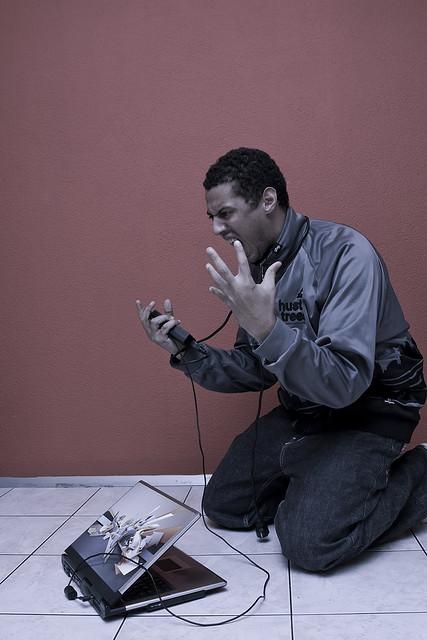Is this man kneeling on linoleum?
Concise answer only. Yes. Is this a cozy room?
Short answer required. No. What emotion is this man feeling?
Write a very short answer. Anger. Is it sunny?
Concise answer only. No. What is the person doing?
Write a very short answer. Screaming. 